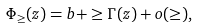Convert formula to latex. <formula><loc_0><loc_0><loc_500><loc_500>\Phi _ { \geq } ( z ) = b + \geq \Gamma ( z ) + o ( \geq ) ,</formula> 